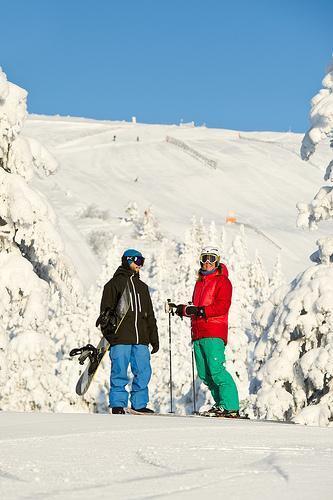How many people are there?
Give a very brief answer. 2. 